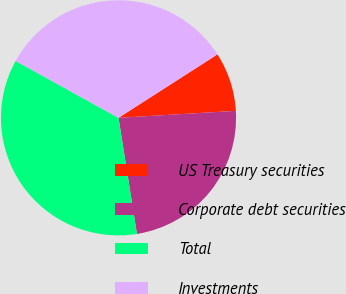<chart> <loc_0><loc_0><loc_500><loc_500><pie_chart><fcel>US Treasury securities<fcel>Corporate debt securities<fcel>Total<fcel>Investments<nl><fcel>8.13%<fcel>23.44%<fcel>35.55%<fcel>32.89%<nl></chart> 